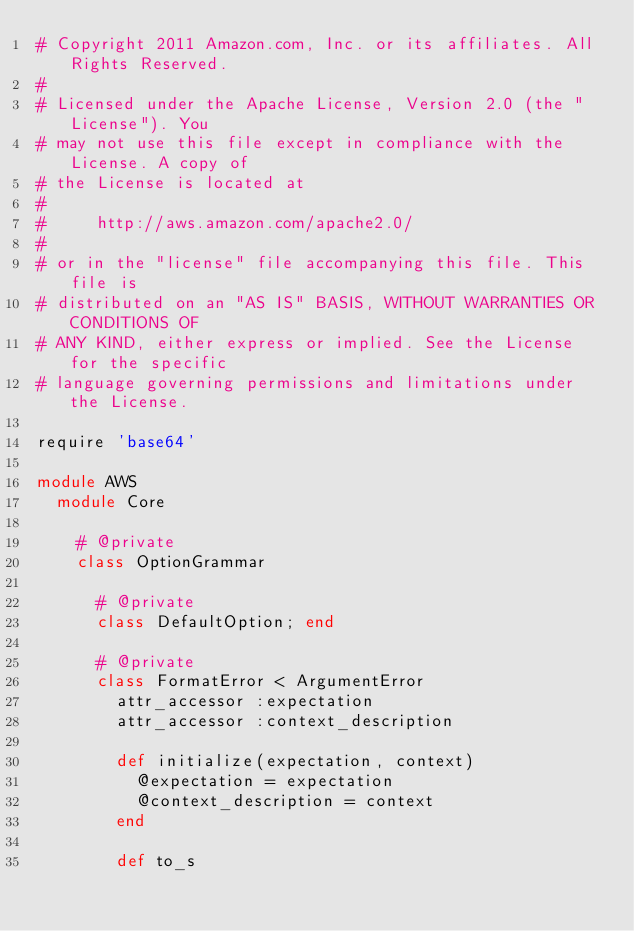<code> <loc_0><loc_0><loc_500><loc_500><_Ruby_># Copyright 2011 Amazon.com, Inc. or its affiliates. All Rights Reserved.
#
# Licensed under the Apache License, Version 2.0 (the "License"). You
# may not use this file except in compliance with the License. A copy of
# the License is located at
#
#     http://aws.amazon.com/apache2.0/
#
# or in the "license" file accompanying this file. This file is
# distributed on an "AS IS" BASIS, WITHOUT WARRANTIES OR CONDITIONS OF
# ANY KIND, either express or implied. See the License for the specific
# language governing permissions and limitations under the License.

require 'base64'

module AWS
  module Core

    # @private
    class OptionGrammar
  
      # @private
      class DefaultOption; end
  
      # @private
      class FormatError < ArgumentError
        attr_accessor :expectation
        attr_accessor :context_description
  
        def initialize(expectation, context)
          @expectation = expectation
          @context_description = context
        end
  
        def to_s</code> 